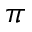Convert formula to latex. <formula><loc_0><loc_0><loc_500><loc_500>\pi</formula> 